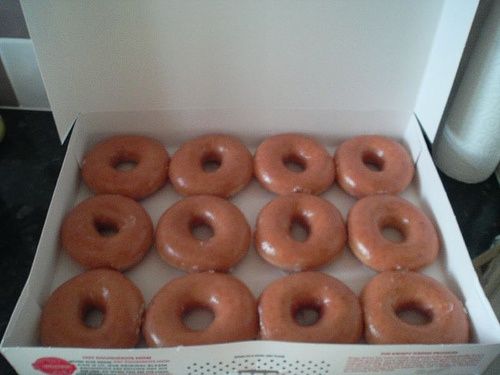Describe the objects in this image and their specific colors. I can see dining table in purple, black, darkgreen, and gray tones, donut in purple, brown, and maroon tones, donut in purple, maroon, brown, black, and gray tones, donut in purple, brown, and maroon tones, and donut in purple, brown, and maroon tones in this image. 